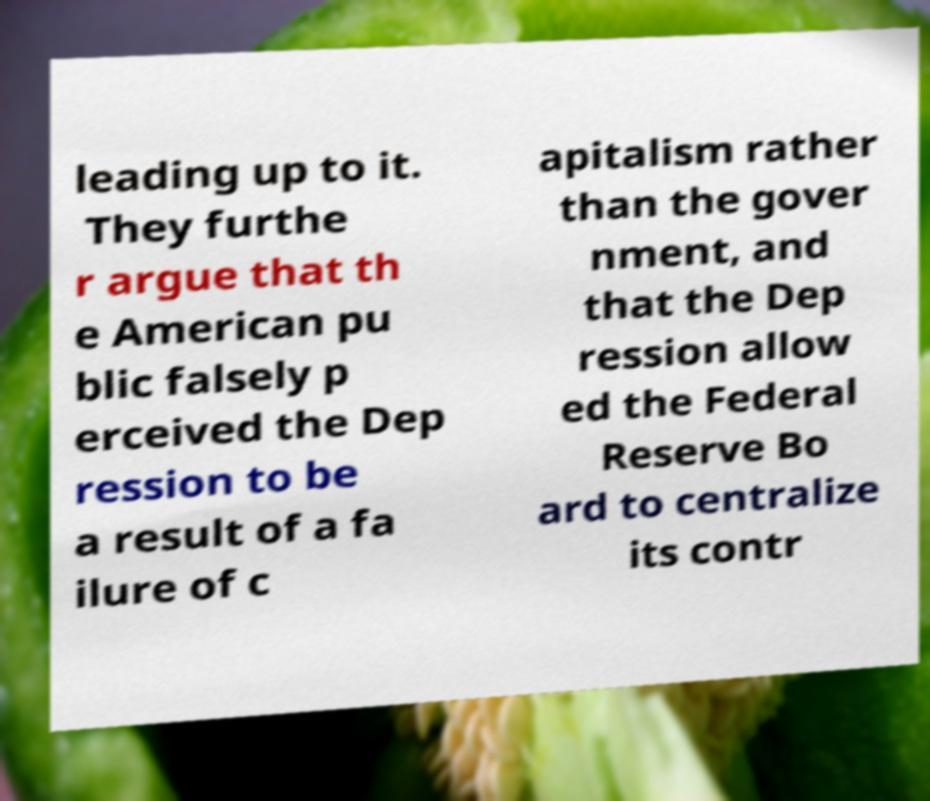There's text embedded in this image that I need extracted. Can you transcribe it verbatim? leading up to it. They furthe r argue that th e American pu blic falsely p erceived the Dep ression to be a result of a fa ilure of c apitalism rather than the gover nment, and that the Dep ression allow ed the Federal Reserve Bo ard to centralize its contr 